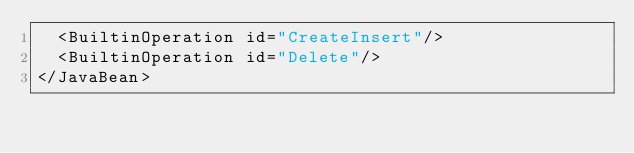<code> <loc_0><loc_0><loc_500><loc_500><_XML_>  <BuiltinOperation id="CreateInsert"/>
  <BuiltinOperation id="Delete"/>
</JavaBean>
</code> 